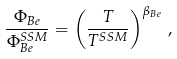<formula> <loc_0><loc_0><loc_500><loc_500>\frac { \Phi _ { B e } } { \Phi _ { B e } ^ { S S M } } = \left ( \frac { T } { T ^ { S S M } } \right ) ^ { \beta _ { B e } } \, ,</formula> 